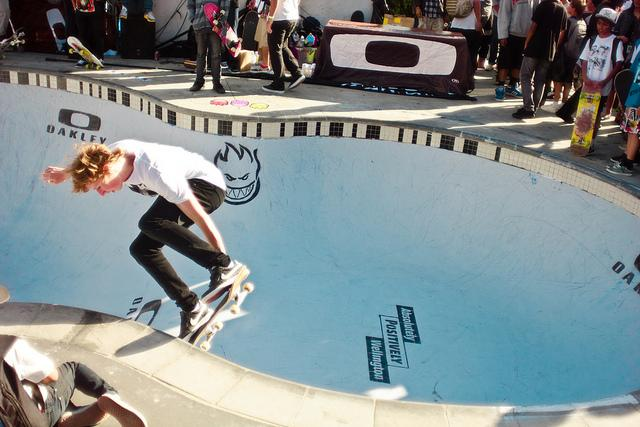What's happening to this guy? falling 